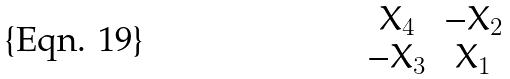Convert formula to latex. <formula><loc_0><loc_0><loc_500><loc_500>\begin{matrix} X _ { 4 } & - X _ { 2 } \\ - X _ { 3 } & X _ { 1 } \end{matrix}</formula> 